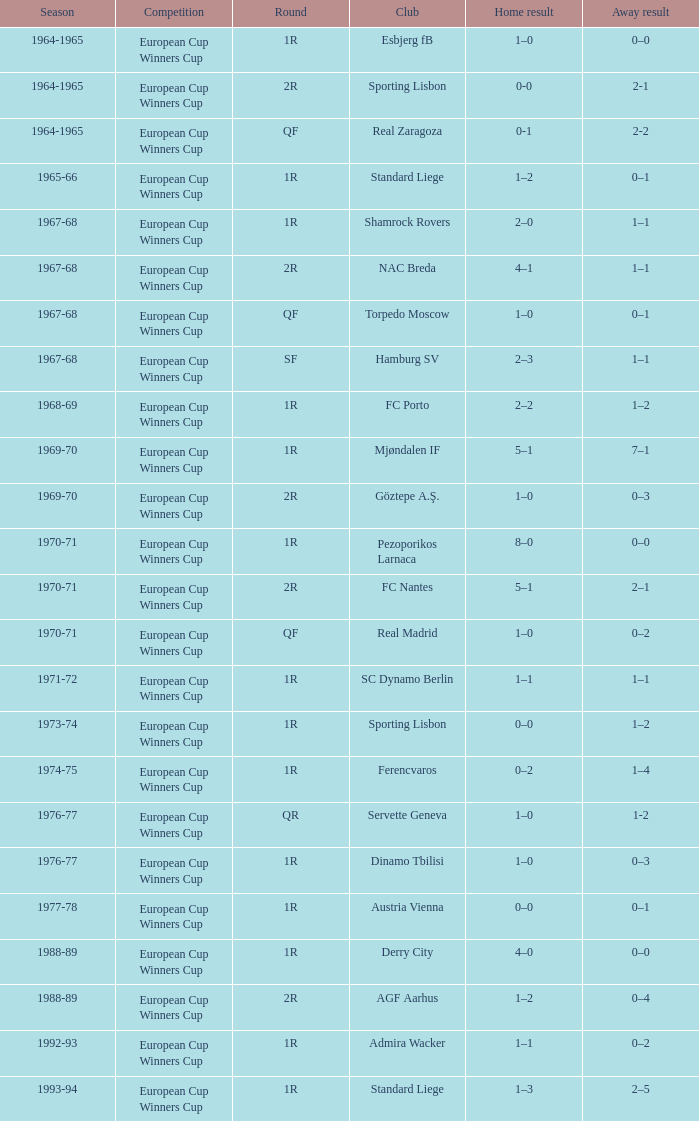Away result of 1–1, and a Round of 1r, and a Season of 1967-68 involves what club? Shamrock Rovers. 